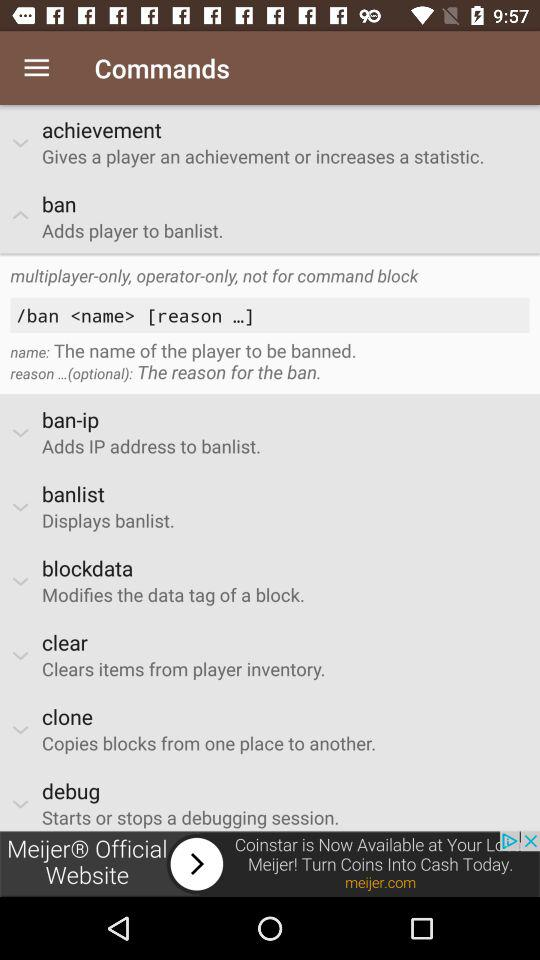What is the command to display the banlist? The command is "banlist" to display the banlist. 